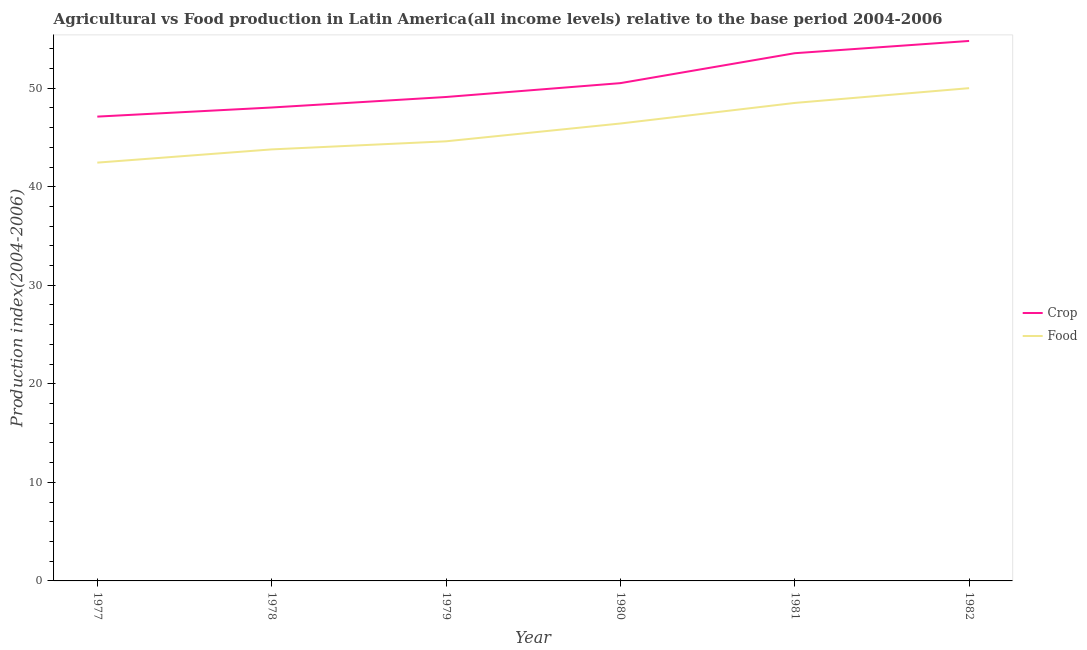How many different coloured lines are there?
Make the answer very short. 2. Does the line corresponding to crop production index intersect with the line corresponding to food production index?
Give a very brief answer. No. Is the number of lines equal to the number of legend labels?
Your response must be concise. Yes. What is the food production index in 1980?
Make the answer very short. 46.42. Across all years, what is the maximum food production index?
Your answer should be very brief. 50. Across all years, what is the minimum food production index?
Offer a terse response. 42.45. In which year was the food production index maximum?
Offer a terse response. 1982. What is the total crop production index in the graph?
Keep it short and to the point. 303.12. What is the difference between the crop production index in 1980 and that in 1981?
Your answer should be very brief. -3.04. What is the difference between the crop production index in 1980 and the food production index in 1978?
Provide a short and direct response. 6.72. What is the average food production index per year?
Ensure brevity in your answer.  45.96. In the year 1979, what is the difference between the crop production index and food production index?
Keep it short and to the point. 4.5. In how many years, is the crop production index greater than 2?
Make the answer very short. 6. What is the ratio of the crop production index in 1980 to that in 1982?
Make the answer very short. 0.92. Is the food production index in 1980 less than that in 1982?
Provide a short and direct response. Yes. Is the difference between the food production index in 1978 and 1980 greater than the difference between the crop production index in 1978 and 1980?
Your answer should be very brief. No. What is the difference between the highest and the second highest crop production index?
Give a very brief answer. 1.24. What is the difference between the highest and the lowest crop production index?
Offer a very short reply. 7.68. Is the crop production index strictly greater than the food production index over the years?
Provide a succinct answer. Yes. Are the values on the major ticks of Y-axis written in scientific E-notation?
Your answer should be compact. No. Where does the legend appear in the graph?
Give a very brief answer. Center right. How are the legend labels stacked?
Keep it short and to the point. Vertical. What is the title of the graph?
Your answer should be very brief. Agricultural vs Food production in Latin America(all income levels) relative to the base period 2004-2006. What is the label or title of the X-axis?
Your answer should be very brief. Year. What is the label or title of the Y-axis?
Your answer should be very brief. Production index(2004-2006). What is the Production index(2004-2006) in Crop in 1977?
Provide a succinct answer. 47.12. What is the Production index(2004-2006) of Food in 1977?
Your response must be concise. 42.45. What is the Production index(2004-2006) in Crop in 1978?
Ensure brevity in your answer.  48.04. What is the Production index(2004-2006) in Food in 1978?
Give a very brief answer. 43.79. What is the Production index(2004-2006) of Crop in 1979?
Keep it short and to the point. 49.11. What is the Production index(2004-2006) of Food in 1979?
Make the answer very short. 44.61. What is the Production index(2004-2006) of Crop in 1980?
Give a very brief answer. 50.51. What is the Production index(2004-2006) in Food in 1980?
Your response must be concise. 46.42. What is the Production index(2004-2006) in Crop in 1981?
Your answer should be very brief. 53.55. What is the Production index(2004-2006) in Food in 1981?
Keep it short and to the point. 48.5. What is the Production index(2004-2006) in Crop in 1982?
Offer a terse response. 54.79. What is the Production index(2004-2006) of Food in 1982?
Provide a succinct answer. 50. Across all years, what is the maximum Production index(2004-2006) in Crop?
Offer a very short reply. 54.79. Across all years, what is the maximum Production index(2004-2006) of Food?
Provide a succinct answer. 50. Across all years, what is the minimum Production index(2004-2006) in Crop?
Keep it short and to the point. 47.12. Across all years, what is the minimum Production index(2004-2006) of Food?
Offer a very short reply. 42.45. What is the total Production index(2004-2006) of Crop in the graph?
Keep it short and to the point. 303.12. What is the total Production index(2004-2006) of Food in the graph?
Ensure brevity in your answer.  275.77. What is the difference between the Production index(2004-2006) of Crop in 1977 and that in 1978?
Your answer should be compact. -0.93. What is the difference between the Production index(2004-2006) in Food in 1977 and that in 1978?
Your response must be concise. -1.34. What is the difference between the Production index(2004-2006) in Crop in 1977 and that in 1979?
Your response must be concise. -1.99. What is the difference between the Production index(2004-2006) of Food in 1977 and that in 1979?
Your answer should be compact. -2.16. What is the difference between the Production index(2004-2006) of Crop in 1977 and that in 1980?
Offer a very short reply. -3.4. What is the difference between the Production index(2004-2006) of Food in 1977 and that in 1980?
Provide a succinct answer. -3.97. What is the difference between the Production index(2004-2006) in Crop in 1977 and that in 1981?
Offer a terse response. -6.43. What is the difference between the Production index(2004-2006) in Food in 1977 and that in 1981?
Offer a terse response. -6.06. What is the difference between the Production index(2004-2006) of Crop in 1977 and that in 1982?
Make the answer very short. -7.68. What is the difference between the Production index(2004-2006) of Food in 1977 and that in 1982?
Make the answer very short. -7.56. What is the difference between the Production index(2004-2006) in Crop in 1978 and that in 1979?
Offer a terse response. -1.07. What is the difference between the Production index(2004-2006) in Food in 1978 and that in 1979?
Your response must be concise. -0.82. What is the difference between the Production index(2004-2006) in Crop in 1978 and that in 1980?
Provide a short and direct response. -2.47. What is the difference between the Production index(2004-2006) of Food in 1978 and that in 1980?
Ensure brevity in your answer.  -2.63. What is the difference between the Production index(2004-2006) in Crop in 1978 and that in 1981?
Your answer should be very brief. -5.51. What is the difference between the Production index(2004-2006) in Food in 1978 and that in 1981?
Provide a succinct answer. -4.72. What is the difference between the Production index(2004-2006) in Crop in 1978 and that in 1982?
Your response must be concise. -6.75. What is the difference between the Production index(2004-2006) in Food in 1978 and that in 1982?
Ensure brevity in your answer.  -6.21. What is the difference between the Production index(2004-2006) of Crop in 1979 and that in 1980?
Provide a short and direct response. -1.41. What is the difference between the Production index(2004-2006) of Food in 1979 and that in 1980?
Provide a succinct answer. -1.81. What is the difference between the Production index(2004-2006) of Crop in 1979 and that in 1981?
Ensure brevity in your answer.  -4.44. What is the difference between the Production index(2004-2006) in Food in 1979 and that in 1981?
Offer a very short reply. -3.89. What is the difference between the Production index(2004-2006) of Crop in 1979 and that in 1982?
Ensure brevity in your answer.  -5.69. What is the difference between the Production index(2004-2006) in Food in 1979 and that in 1982?
Your response must be concise. -5.39. What is the difference between the Production index(2004-2006) of Crop in 1980 and that in 1981?
Ensure brevity in your answer.  -3.04. What is the difference between the Production index(2004-2006) of Food in 1980 and that in 1981?
Your answer should be compact. -2.09. What is the difference between the Production index(2004-2006) in Crop in 1980 and that in 1982?
Your answer should be compact. -4.28. What is the difference between the Production index(2004-2006) of Food in 1980 and that in 1982?
Offer a very short reply. -3.59. What is the difference between the Production index(2004-2006) of Crop in 1981 and that in 1982?
Offer a very short reply. -1.24. What is the difference between the Production index(2004-2006) of Food in 1981 and that in 1982?
Make the answer very short. -1.5. What is the difference between the Production index(2004-2006) of Crop in 1977 and the Production index(2004-2006) of Food in 1978?
Provide a succinct answer. 3.33. What is the difference between the Production index(2004-2006) in Crop in 1977 and the Production index(2004-2006) in Food in 1979?
Your answer should be very brief. 2.51. What is the difference between the Production index(2004-2006) in Crop in 1977 and the Production index(2004-2006) in Food in 1980?
Keep it short and to the point. 0.7. What is the difference between the Production index(2004-2006) in Crop in 1977 and the Production index(2004-2006) in Food in 1981?
Provide a succinct answer. -1.39. What is the difference between the Production index(2004-2006) in Crop in 1977 and the Production index(2004-2006) in Food in 1982?
Your response must be concise. -2.89. What is the difference between the Production index(2004-2006) in Crop in 1978 and the Production index(2004-2006) in Food in 1979?
Offer a terse response. 3.43. What is the difference between the Production index(2004-2006) of Crop in 1978 and the Production index(2004-2006) of Food in 1980?
Provide a short and direct response. 1.62. What is the difference between the Production index(2004-2006) in Crop in 1978 and the Production index(2004-2006) in Food in 1981?
Your answer should be compact. -0.46. What is the difference between the Production index(2004-2006) in Crop in 1978 and the Production index(2004-2006) in Food in 1982?
Give a very brief answer. -1.96. What is the difference between the Production index(2004-2006) in Crop in 1979 and the Production index(2004-2006) in Food in 1980?
Offer a very short reply. 2.69. What is the difference between the Production index(2004-2006) in Crop in 1979 and the Production index(2004-2006) in Food in 1981?
Offer a terse response. 0.6. What is the difference between the Production index(2004-2006) of Crop in 1979 and the Production index(2004-2006) of Food in 1982?
Your answer should be compact. -0.9. What is the difference between the Production index(2004-2006) of Crop in 1980 and the Production index(2004-2006) of Food in 1981?
Offer a terse response. 2.01. What is the difference between the Production index(2004-2006) in Crop in 1980 and the Production index(2004-2006) in Food in 1982?
Provide a succinct answer. 0.51. What is the difference between the Production index(2004-2006) in Crop in 1981 and the Production index(2004-2006) in Food in 1982?
Keep it short and to the point. 3.55. What is the average Production index(2004-2006) of Crop per year?
Keep it short and to the point. 50.52. What is the average Production index(2004-2006) of Food per year?
Your response must be concise. 45.96. In the year 1977, what is the difference between the Production index(2004-2006) of Crop and Production index(2004-2006) of Food?
Give a very brief answer. 4.67. In the year 1978, what is the difference between the Production index(2004-2006) in Crop and Production index(2004-2006) in Food?
Offer a very short reply. 4.25. In the year 1979, what is the difference between the Production index(2004-2006) in Crop and Production index(2004-2006) in Food?
Keep it short and to the point. 4.5. In the year 1980, what is the difference between the Production index(2004-2006) of Crop and Production index(2004-2006) of Food?
Provide a short and direct response. 4.1. In the year 1981, what is the difference between the Production index(2004-2006) of Crop and Production index(2004-2006) of Food?
Provide a succinct answer. 5.05. In the year 1982, what is the difference between the Production index(2004-2006) in Crop and Production index(2004-2006) in Food?
Provide a succinct answer. 4.79. What is the ratio of the Production index(2004-2006) in Crop in 1977 to that in 1978?
Keep it short and to the point. 0.98. What is the ratio of the Production index(2004-2006) in Food in 1977 to that in 1978?
Provide a succinct answer. 0.97. What is the ratio of the Production index(2004-2006) of Crop in 1977 to that in 1979?
Offer a very short reply. 0.96. What is the ratio of the Production index(2004-2006) in Food in 1977 to that in 1979?
Make the answer very short. 0.95. What is the ratio of the Production index(2004-2006) in Crop in 1977 to that in 1980?
Offer a terse response. 0.93. What is the ratio of the Production index(2004-2006) in Food in 1977 to that in 1980?
Offer a very short reply. 0.91. What is the ratio of the Production index(2004-2006) of Crop in 1977 to that in 1981?
Give a very brief answer. 0.88. What is the ratio of the Production index(2004-2006) in Food in 1977 to that in 1981?
Offer a very short reply. 0.88. What is the ratio of the Production index(2004-2006) of Crop in 1977 to that in 1982?
Your answer should be very brief. 0.86. What is the ratio of the Production index(2004-2006) of Food in 1977 to that in 1982?
Provide a short and direct response. 0.85. What is the ratio of the Production index(2004-2006) in Crop in 1978 to that in 1979?
Ensure brevity in your answer.  0.98. What is the ratio of the Production index(2004-2006) of Food in 1978 to that in 1979?
Offer a very short reply. 0.98. What is the ratio of the Production index(2004-2006) of Crop in 1978 to that in 1980?
Keep it short and to the point. 0.95. What is the ratio of the Production index(2004-2006) in Food in 1978 to that in 1980?
Make the answer very short. 0.94. What is the ratio of the Production index(2004-2006) in Crop in 1978 to that in 1981?
Your answer should be compact. 0.9. What is the ratio of the Production index(2004-2006) in Food in 1978 to that in 1981?
Ensure brevity in your answer.  0.9. What is the ratio of the Production index(2004-2006) of Crop in 1978 to that in 1982?
Keep it short and to the point. 0.88. What is the ratio of the Production index(2004-2006) of Food in 1978 to that in 1982?
Offer a terse response. 0.88. What is the ratio of the Production index(2004-2006) of Crop in 1979 to that in 1980?
Ensure brevity in your answer.  0.97. What is the ratio of the Production index(2004-2006) in Food in 1979 to that in 1980?
Your response must be concise. 0.96. What is the ratio of the Production index(2004-2006) in Crop in 1979 to that in 1981?
Offer a very short reply. 0.92. What is the ratio of the Production index(2004-2006) of Food in 1979 to that in 1981?
Your response must be concise. 0.92. What is the ratio of the Production index(2004-2006) in Crop in 1979 to that in 1982?
Give a very brief answer. 0.9. What is the ratio of the Production index(2004-2006) of Food in 1979 to that in 1982?
Make the answer very short. 0.89. What is the ratio of the Production index(2004-2006) in Crop in 1980 to that in 1981?
Provide a short and direct response. 0.94. What is the ratio of the Production index(2004-2006) of Crop in 1980 to that in 1982?
Give a very brief answer. 0.92. What is the ratio of the Production index(2004-2006) in Food in 1980 to that in 1982?
Your response must be concise. 0.93. What is the ratio of the Production index(2004-2006) in Crop in 1981 to that in 1982?
Your answer should be very brief. 0.98. What is the ratio of the Production index(2004-2006) of Food in 1981 to that in 1982?
Your answer should be compact. 0.97. What is the difference between the highest and the second highest Production index(2004-2006) in Crop?
Offer a terse response. 1.24. What is the difference between the highest and the second highest Production index(2004-2006) of Food?
Provide a succinct answer. 1.5. What is the difference between the highest and the lowest Production index(2004-2006) in Crop?
Your answer should be very brief. 7.68. What is the difference between the highest and the lowest Production index(2004-2006) of Food?
Offer a terse response. 7.56. 